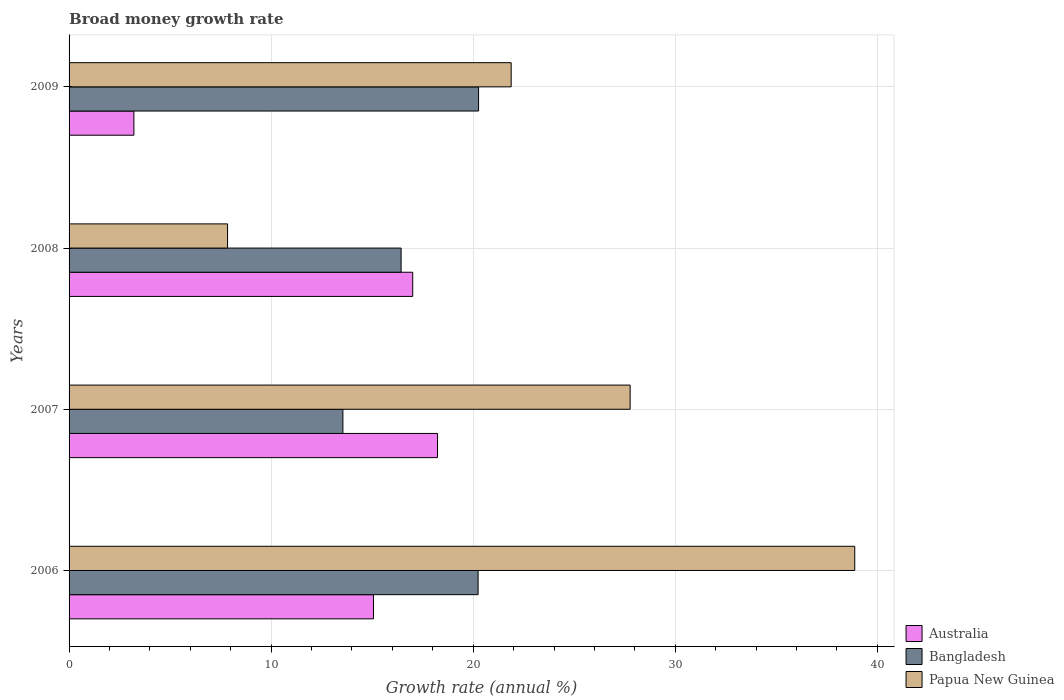How many different coloured bars are there?
Offer a terse response. 3. How many bars are there on the 1st tick from the top?
Keep it short and to the point. 3. How many bars are there on the 1st tick from the bottom?
Your answer should be very brief. 3. What is the label of the 4th group of bars from the top?
Keep it short and to the point. 2006. In how many cases, is the number of bars for a given year not equal to the number of legend labels?
Offer a terse response. 0. What is the growth rate in Bangladesh in 2006?
Your answer should be compact. 20.24. Across all years, what is the maximum growth rate in Papua New Guinea?
Make the answer very short. 38.88. Across all years, what is the minimum growth rate in Bangladesh?
Keep it short and to the point. 13.55. In which year was the growth rate in Australia maximum?
Keep it short and to the point. 2007. In which year was the growth rate in Bangladesh minimum?
Your response must be concise. 2007. What is the total growth rate in Papua New Guinea in the graph?
Your answer should be very brief. 96.36. What is the difference between the growth rate in Papua New Guinea in 2006 and that in 2009?
Your response must be concise. 17. What is the difference between the growth rate in Bangladesh in 2006 and the growth rate in Papua New Guinea in 2009?
Your response must be concise. -1.64. What is the average growth rate in Bangladesh per year?
Your answer should be very brief. 17.62. In the year 2008, what is the difference between the growth rate in Australia and growth rate in Papua New Guinea?
Your answer should be compact. 9.16. In how many years, is the growth rate in Papua New Guinea greater than 38 %?
Offer a terse response. 1. What is the ratio of the growth rate in Bangladesh in 2006 to that in 2008?
Keep it short and to the point. 1.23. What is the difference between the highest and the second highest growth rate in Bangladesh?
Ensure brevity in your answer.  0.02. What is the difference between the highest and the lowest growth rate in Australia?
Provide a succinct answer. 15.03. In how many years, is the growth rate in Papua New Guinea greater than the average growth rate in Papua New Guinea taken over all years?
Your answer should be very brief. 2. What does the 2nd bar from the top in 2006 represents?
Keep it short and to the point. Bangladesh. What does the 3rd bar from the bottom in 2008 represents?
Keep it short and to the point. Papua New Guinea. Is it the case that in every year, the sum of the growth rate in Australia and growth rate in Papua New Guinea is greater than the growth rate in Bangladesh?
Give a very brief answer. Yes. How many bars are there?
Offer a very short reply. 12. Are all the bars in the graph horizontal?
Offer a very short reply. Yes. How many years are there in the graph?
Offer a very short reply. 4. Does the graph contain grids?
Provide a short and direct response. Yes. Where does the legend appear in the graph?
Offer a terse response. Bottom right. What is the title of the graph?
Provide a succinct answer. Broad money growth rate. Does "Kyrgyz Republic" appear as one of the legend labels in the graph?
Provide a short and direct response. No. What is the label or title of the X-axis?
Offer a very short reply. Growth rate (annual %). What is the label or title of the Y-axis?
Keep it short and to the point. Years. What is the Growth rate (annual %) of Australia in 2006?
Ensure brevity in your answer.  15.06. What is the Growth rate (annual %) of Bangladesh in 2006?
Give a very brief answer. 20.24. What is the Growth rate (annual %) in Papua New Guinea in 2006?
Your answer should be very brief. 38.88. What is the Growth rate (annual %) of Australia in 2007?
Provide a succinct answer. 18.23. What is the Growth rate (annual %) in Bangladesh in 2007?
Your answer should be very brief. 13.55. What is the Growth rate (annual %) of Papua New Guinea in 2007?
Give a very brief answer. 27.76. What is the Growth rate (annual %) of Australia in 2008?
Make the answer very short. 17. What is the Growth rate (annual %) in Bangladesh in 2008?
Your response must be concise. 16.43. What is the Growth rate (annual %) in Papua New Guinea in 2008?
Your answer should be very brief. 7.84. What is the Growth rate (annual %) in Australia in 2009?
Ensure brevity in your answer.  3.21. What is the Growth rate (annual %) in Bangladesh in 2009?
Provide a short and direct response. 20.26. What is the Growth rate (annual %) in Papua New Guinea in 2009?
Make the answer very short. 21.88. Across all years, what is the maximum Growth rate (annual %) of Australia?
Make the answer very short. 18.23. Across all years, what is the maximum Growth rate (annual %) in Bangladesh?
Offer a very short reply. 20.26. Across all years, what is the maximum Growth rate (annual %) of Papua New Guinea?
Your answer should be compact. 38.88. Across all years, what is the minimum Growth rate (annual %) of Australia?
Offer a very short reply. 3.21. Across all years, what is the minimum Growth rate (annual %) in Bangladesh?
Offer a very short reply. 13.55. Across all years, what is the minimum Growth rate (annual %) of Papua New Guinea?
Offer a terse response. 7.84. What is the total Growth rate (annual %) of Australia in the graph?
Your answer should be compact. 53.51. What is the total Growth rate (annual %) of Bangladesh in the graph?
Keep it short and to the point. 70.49. What is the total Growth rate (annual %) of Papua New Guinea in the graph?
Your answer should be very brief. 96.36. What is the difference between the Growth rate (annual %) in Australia in 2006 and that in 2007?
Keep it short and to the point. -3.17. What is the difference between the Growth rate (annual %) of Bangladesh in 2006 and that in 2007?
Provide a short and direct response. 6.69. What is the difference between the Growth rate (annual %) in Papua New Guinea in 2006 and that in 2007?
Ensure brevity in your answer.  11.11. What is the difference between the Growth rate (annual %) in Australia in 2006 and that in 2008?
Your answer should be very brief. -1.94. What is the difference between the Growth rate (annual %) in Bangladesh in 2006 and that in 2008?
Make the answer very short. 3.81. What is the difference between the Growth rate (annual %) in Papua New Guinea in 2006 and that in 2008?
Offer a very short reply. 31.04. What is the difference between the Growth rate (annual %) of Australia in 2006 and that in 2009?
Your answer should be very brief. 11.86. What is the difference between the Growth rate (annual %) in Bangladesh in 2006 and that in 2009?
Provide a short and direct response. -0.02. What is the difference between the Growth rate (annual %) of Papua New Guinea in 2006 and that in 2009?
Offer a terse response. 17. What is the difference between the Growth rate (annual %) of Australia in 2007 and that in 2008?
Provide a succinct answer. 1.23. What is the difference between the Growth rate (annual %) of Bangladesh in 2007 and that in 2008?
Offer a terse response. -2.88. What is the difference between the Growth rate (annual %) in Papua New Guinea in 2007 and that in 2008?
Provide a short and direct response. 19.92. What is the difference between the Growth rate (annual %) in Australia in 2007 and that in 2009?
Make the answer very short. 15.03. What is the difference between the Growth rate (annual %) of Bangladesh in 2007 and that in 2009?
Offer a terse response. -6.71. What is the difference between the Growth rate (annual %) of Papua New Guinea in 2007 and that in 2009?
Provide a short and direct response. 5.89. What is the difference between the Growth rate (annual %) in Australia in 2008 and that in 2009?
Offer a very short reply. 13.8. What is the difference between the Growth rate (annual %) in Bangladesh in 2008 and that in 2009?
Keep it short and to the point. -3.83. What is the difference between the Growth rate (annual %) of Papua New Guinea in 2008 and that in 2009?
Provide a succinct answer. -14.03. What is the difference between the Growth rate (annual %) of Australia in 2006 and the Growth rate (annual %) of Bangladesh in 2007?
Provide a short and direct response. 1.51. What is the difference between the Growth rate (annual %) in Australia in 2006 and the Growth rate (annual %) in Papua New Guinea in 2007?
Provide a succinct answer. -12.7. What is the difference between the Growth rate (annual %) in Bangladesh in 2006 and the Growth rate (annual %) in Papua New Guinea in 2007?
Your response must be concise. -7.52. What is the difference between the Growth rate (annual %) of Australia in 2006 and the Growth rate (annual %) of Bangladesh in 2008?
Make the answer very short. -1.37. What is the difference between the Growth rate (annual %) in Australia in 2006 and the Growth rate (annual %) in Papua New Guinea in 2008?
Provide a short and direct response. 7.22. What is the difference between the Growth rate (annual %) in Bangladesh in 2006 and the Growth rate (annual %) in Papua New Guinea in 2008?
Give a very brief answer. 12.4. What is the difference between the Growth rate (annual %) in Australia in 2006 and the Growth rate (annual %) in Bangladesh in 2009?
Offer a terse response. -5.2. What is the difference between the Growth rate (annual %) in Australia in 2006 and the Growth rate (annual %) in Papua New Guinea in 2009?
Your answer should be very brief. -6.81. What is the difference between the Growth rate (annual %) of Bangladesh in 2006 and the Growth rate (annual %) of Papua New Guinea in 2009?
Your answer should be very brief. -1.64. What is the difference between the Growth rate (annual %) in Australia in 2007 and the Growth rate (annual %) in Bangladesh in 2008?
Your answer should be very brief. 1.8. What is the difference between the Growth rate (annual %) of Australia in 2007 and the Growth rate (annual %) of Papua New Guinea in 2008?
Your answer should be very brief. 10.39. What is the difference between the Growth rate (annual %) of Bangladesh in 2007 and the Growth rate (annual %) of Papua New Guinea in 2008?
Your answer should be compact. 5.71. What is the difference between the Growth rate (annual %) in Australia in 2007 and the Growth rate (annual %) in Bangladesh in 2009?
Your response must be concise. -2.03. What is the difference between the Growth rate (annual %) in Australia in 2007 and the Growth rate (annual %) in Papua New Guinea in 2009?
Make the answer very short. -3.64. What is the difference between the Growth rate (annual %) of Bangladesh in 2007 and the Growth rate (annual %) of Papua New Guinea in 2009?
Keep it short and to the point. -8.33. What is the difference between the Growth rate (annual %) in Australia in 2008 and the Growth rate (annual %) in Bangladesh in 2009?
Offer a terse response. -3.26. What is the difference between the Growth rate (annual %) of Australia in 2008 and the Growth rate (annual %) of Papua New Guinea in 2009?
Provide a succinct answer. -4.87. What is the difference between the Growth rate (annual %) of Bangladesh in 2008 and the Growth rate (annual %) of Papua New Guinea in 2009?
Your answer should be very brief. -5.45. What is the average Growth rate (annual %) of Australia per year?
Give a very brief answer. 13.38. What is the average Growth rate (annual %) in Bangladesh per year?
Your answer should be compact. 17.62. What is the average Growth rate (annual %) in Papua New Guinea per year?
Provide a short and direct response. 24.09. In the year 2006, what is the difference between the Growth rate (annual %) of Australia and Growth rate (annual %) of Bangladesh?
Keep it short and to the point. -5.18. In the year 2006, what is the difference between the Growth rate (annual %) in Australia and Growth rate (annual %) in Papua New Guinea?
Offer a very short reply. -23.82. In the year 2006, what is the difference between the Growth rate (annual %) in Bangladesh and Growth rate (annual %) in Papua New Guinea?
Your answer should be very brief. -18.64. In the year 2007, what is the difference between the Growth rate (annual %) in Australia and Growth rate (annual %) in Bangladesh?
Offer a terse response. 4.68. In the year 2007, what is the difference between the Growth rate (annual %) of Australia and Growth rate (annual %) of Papua New Guinea?
Give a very brief answer. -9.53. In the year 2007, what is the difference between the Growth rate (annual %) of Bangladesh and Growth rate (annual %) of Papua New Guinea?
Provide a short and direct response. -14.21. In the year 2008, what is the difference between the Growth rate (annual %) in Australia and Growth rate (annual %) in Bangladesh?
Your answer should be very brief. 0.57. In the year 2008, what is the difference between the Growth rate (annual %) of Australia and Growth rate (annual %) of Papua New Guinea?
Ensure brevity in your answer.  9.16. In the year 2008, what is the difference between the Growth rate (annual %) of Bangladesh and Growth rate (annual %) of Papua New Guinea?
Offer a very short reply. 8.59. In the year 2009, what is the difference between the Growth rate (annual %) of Australia and Growth rate (annual %) of Bangladesh?
Offer a very short reply. -17.06. In the year 2009, what is the difference between the Growth rate (annual %) of Australia and Growth rate (annual %) of Papua New Guinea?
Offer a very short reply. -18.67. In the year 2009, what is the difference between the Growth rate (annual %) in Bangladesh and Growth rate (annual %) in Papua New Guinea?
Give a very brief answer. -1.61. What is the ratio of the Growth rate (annual %) of Australia in 2006 to that in 2007?
Your response must be concise. 0.83. What is the ratio of the Growth rate (annual %) in Bangladesh in 2006 to that in 2007?
Offer a terse response. 1.49. What is the ratio of the Growth rate (annual %) of Papua New Guinea in 2006 to that in 2007?
Offer a very short reply. 1.4. What is the ratio of the Growth rate (annual %) in Australia in 2006 to that in 2008?
Ensure brevity in your answer.  0.89. What is the ratio of the Growth rate (annual %) in Bangladesh in 2006 to that in 2008?
Keep it short and to the point. 1.23. What is the ratio of the Growth rate (annual %) in Papua New Guinea in 2006 to that in 2008?
Offer a terse response. 4.96. What is the ratio of the Growth rate (annual %) in Australia in 2006 to that in 2009?
Give a very brief answer. 4.7. What is the ratio of the Growth rate (annual %) of Papua New Guinea in 2006 to that in 2009?
Offer a terse response. 1.78. What is the ratio of the Growth rate (annual %) of Australia in 2007 to that in 2008?
Ensure brevity in your answer.  1.07. What is the ratio of the Growth rate (annual %) in Bangladesh in 2007 to that in 2008?
Your answer should be very brief. 0.82. What is the ratio of the Growth rate (annual %) of Papua New Guinea in 2007 to that in 2008?
Ensure brevity in your answer.  3.54. What is the ratio of the Growth rate (annual %) in Australia in 2007 to that in 2009?
Keep it short and to the point. 5.68. What is the ratio of the Growth rate (annual %) in Bangladesh in 2007 to that in 2009?
Your answer should be very brief. 0.67. What is the ratio of the Growth rate (annual %) of Papua New Guinea in 2007 to that in 2009?
Your answer should be very brief. 1.27. What is the ratio of the Growth rate (annual %) of Australia in 2008 to that in 2009?
Your answer should be compact. 5.3. What is the ratio of the Growth rate (annual %) in Bangladesh in 2008 to that in 2009?
Your answer should be very brief. 0.81. What is the ratio of the Growth rate (annual %) in Papua New Guinea in 2008 to that in 2009?
Give a very brief answer. 0.36. What is the difference between the highest and the second highest Growth rate (annual %) in Australia?
Provide a succinct answer. 1.23. What is the difference between the highest and the second highest Growth rate (annual %) in Bangladesh?
Keep it short and to the point. 0.02. What is the difference between the highest and the second highest Growth rate (annual %) in Papua New Guinea?
Provide a succinct answer. 11.11. What is the difference between the highest and the lowest Growth rate (annual %) of Australia?
Provide a succinct answer. 15.03. What is the difference between the highest and the lowest Growth rate (annual %) of Bangladesh?
Offer a terse response. 6.71. What is the difference between the highest and the lowest Growth rate (annual %) of Papua New Guinea?
Your response must be concise. 31.04. 